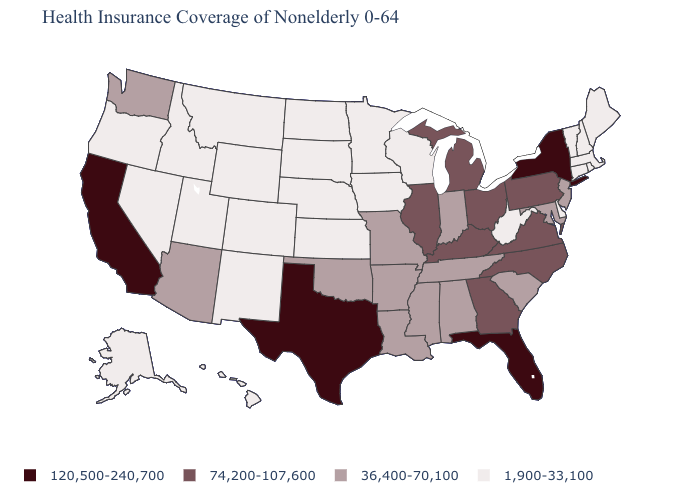Which states have the lowest value in the Northeast?
Write a very short answer. Connecticut, Maine, Massachusetts, New Hampshire, Rhode Island, Vermont. What is the highest value in the USA?
Answer briefly. 120,500-240,700. Name the states that have a value in the range 74,200-107,600?
Be succinct. Georgia, Illinois, Kentucky, Michigan, North Carolina, Ohio, Pennsylvania, Virginia. What is the value of California?
Concise answer only. 120,500-240,700. Does the first symbol in the legend represent the smallest category?
Write a very short answer. No. Name the states that have a value in the range 36,400-70,100?
Write a very short answer. Alabama, Arizona, Arkansas, Indiana, Louisiana, Maryland, Mississippi, Missouri, New Jersey, Oklahoma, South Carolina, Tennessee, Washington. What is the value of South Dakota?
Be succinct. 1,900-33,100. Name the states that have a value in the range 36,400-70,100?
Short answer required. Alabama, Arizona, Arkansas, Indiana, Louisiana, Maryland, Mississippi, Missouri, New Jersey, Oklahoma, South Carolina, Tennessee, Washington. Does Texas have the highest value in the USA?
Write a very short answer. Yes. Does Wyoming have the lowest value in the West?
Keep it brief. Yes. How many symbols are there in the legend?
Write a very short answer. 4. Among the states that border New Hampshire , which have the lowest value?
Answer briefly. Maine, Massachusetts, Vermont. What is the value of West Virginia?
Answer briefly. 1,900-33,100. What is the lowest value in states that border Wyoming?
Short answer required. 1,900-33,100. What is the value of California?
Concise answer only. 120,500-240,700. 